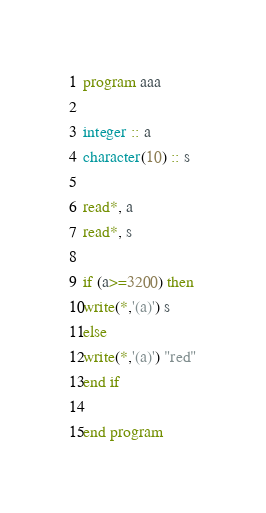Convert code to text. <code><loc_0><loc_0><loc_500><loc_500><_FORTRAN_>program aaa

integer :: a
character(10) :: s

read*, a
read*, s

if (a>=3200) then
write(*,'(a)') s
else
write(*,'(a)') "red"
end if

end program
</code> 